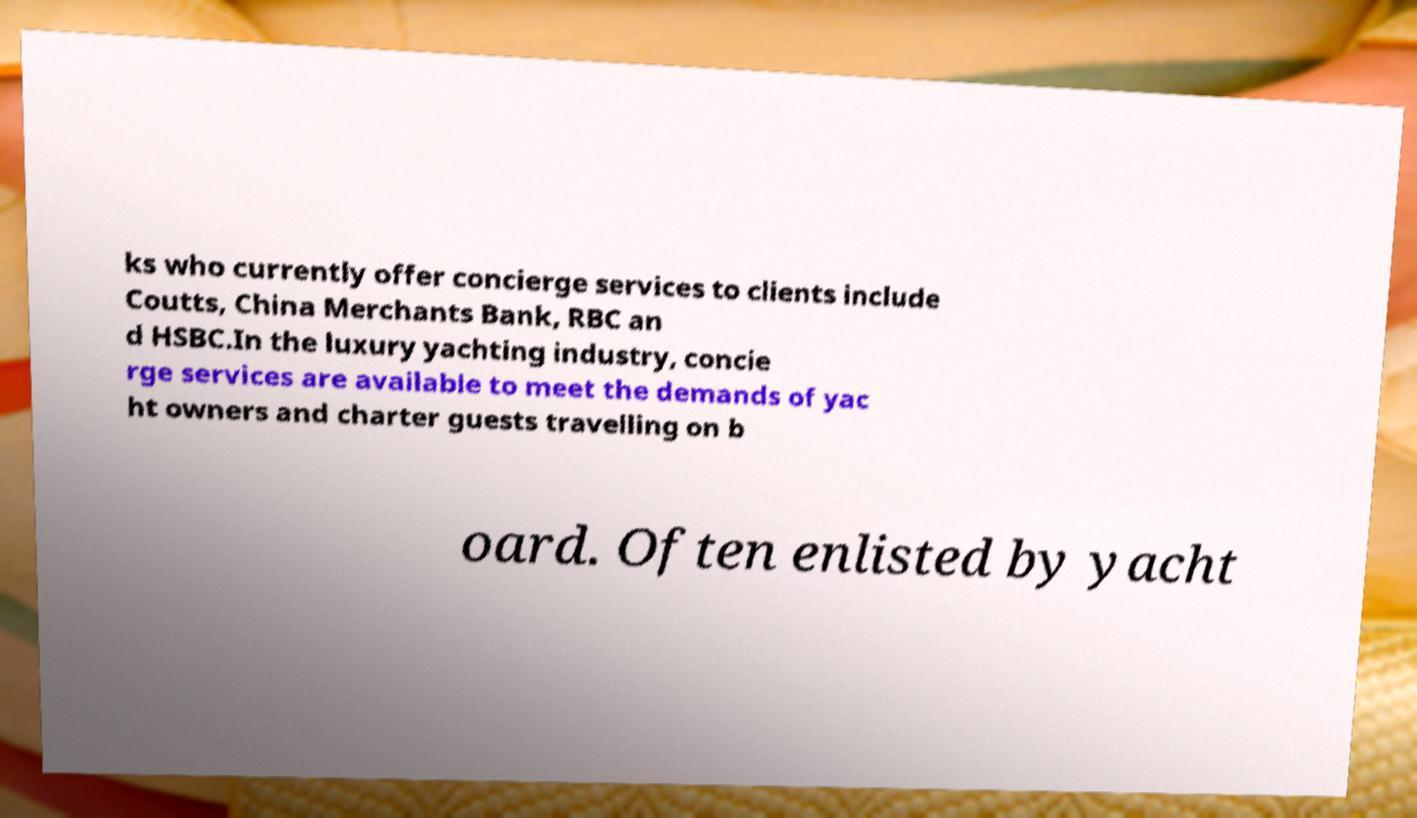Please identify and transcribe the text found in this image. ks who currently offer concierge services to clients include Coutts, China Merchants Bank, RBC an d HSBC.In the luxury yachting industry, concie rge services are available to meet the demands of yac ht owners and charter guests travelling on b oard. Often enlisted by yacht 